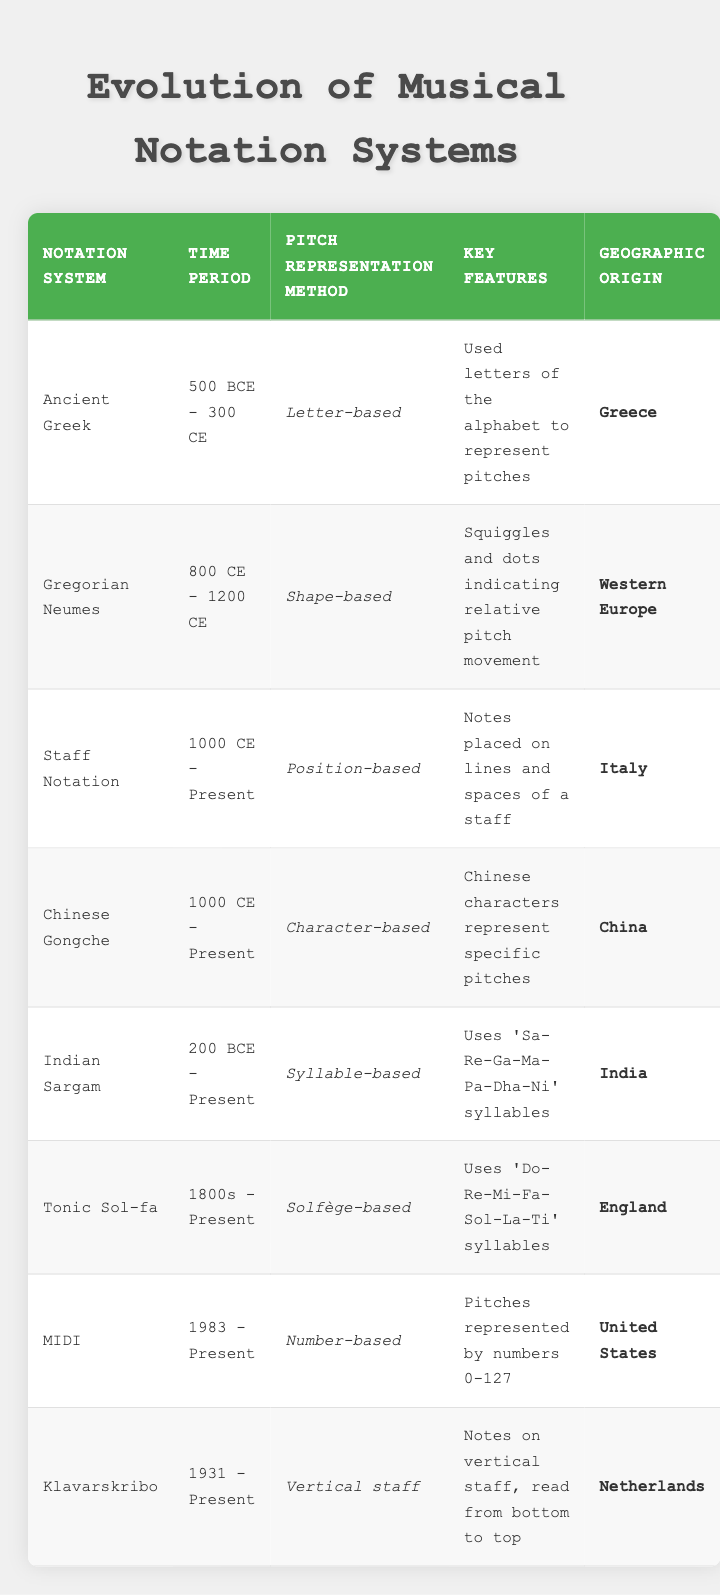What is the pitch representation method used in the Ancient Greek notation system? According to the table, the pitch representation method for the Ancient Greek notation system is "Letter-based."
Answer: Letter-based Which notation system has its geographic origin in China? The table indicates that the "Chinese Gongche" notation system originates from China.
Answer: Chinese Gongche How many pitch representation methods are listed for the time period 1000 CE to present? The table shows two systems—"Staff Notation" and "Chinese Gongche"—that have a time period starting from 1000 CE to the present.
Answer: 2 Is the "Tonic Sol-fa" notation system a syllable-based representation? According to the table, the Tonic Sol-fa system is described as "Solfège-based," not syllable-based, so the statement is false.
Answer: No Which notation system was developed in England? The table shows that "Tonic Sol-fa" is the notation system that originated in England.
Answer: Tonic Sol-fa If you consider the period from 200 BCE to Present, which pitch representation methods would you include? The table indicates that both the "Indian Sargam" and "Staff Notation" have a timeline that includes this period; thus, they are included for that timeframe.
Answer: Indian Sargam, Staff Notation What is the key feature of the MIDI notation system? The table specifies that the key feature of the MIDI system is that pitches are represented by numbers 0-127.
Answer: Numbers 0-127 Among the notation systems listed, which is the only one that uses a vertical staff? From the table, it shows that "Klavarskribo" is the only notation system that employs a vertical staff.
Answer: Klavarskribo Which notation systems use syllables for pitch representation? By analyzing the table, the systems that use syllables for pitch representation are "Indian Sargam" with its syllables and "Tonic Sol-fa" with its solfège syllables.
Answer: Indian Sargam, Tonic Sol-fa 